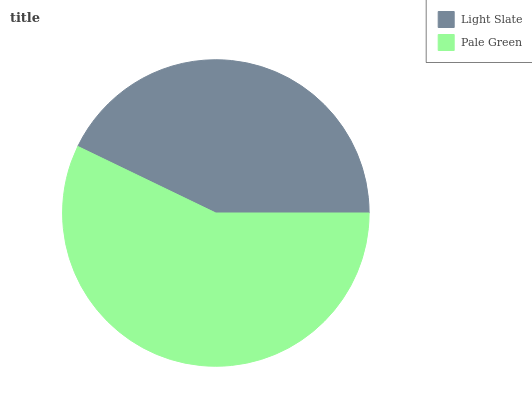Is Light Slate the minimum?
Answer yes or no. Yes. Is Pale Green the maximum?
Answer yes or no. Yes. Is Pale Green the minimum?
Answer yes or no. No. Is Pale Green greater than Light Slate?
Answer yes or no. Yes. Is Light Slate less than Pale Green?
Answer yes or no. Yes. Is Light Slate greater than Pale Green?
Answer yes or no. No. Is Pale Green less than Light Slate?
Answer yes or no. No. Is Pale Green the high median?
Answer yes or no. Yes. Is Light Slate the low median?
Answer yes or no. Yes. Is Light Slate the high median?
Answer yes or no. No. Is Pale Green the low median?
Answer yes or no. No. 